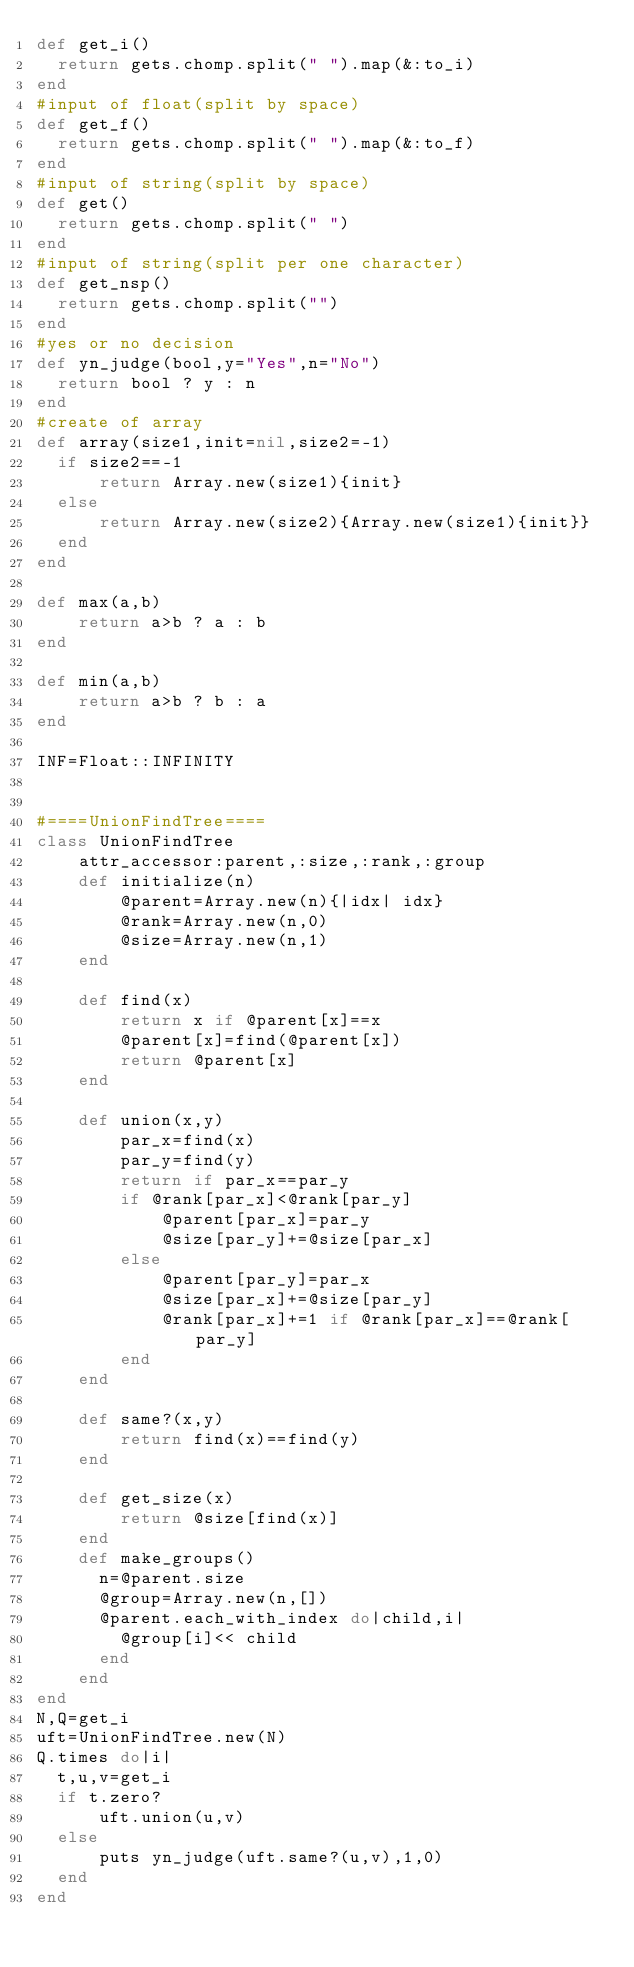Convert code to text. <code><loc_0><loc_0><loc_500><loc_500><_Ruby_>def get_i()
  return gets.chomp.split(" ").map(&:to_i)
end
#input of float(split by space)
def get_f()
  return gets.chomp.split(" ").map(&:to_f)
end
#input of string(split by space)
def get()
  return gets.chomp.split(" ")
end
#input of string(split per one character)
def get_nsp()
  return gets.chomp.split("")
end
#yes or no decision
def yn_judge(bool,y="Yes",n="No")
  return bool ? y : n 
end
#create of array
def array(size1,init=nil,size2=-1)
  if size2==-1
      return Array.new(size1){init}
  else
      return Array.new(size2){Array.new(size1){init}}
  end
end

def max(a,b)
    return a>b ? a : b
end

def min(a,b)
    return a>b ? b : a
end

INF=Float::INFINITY


#====UnionFindTree====
class UnionFindTree
    attr_accessor:parent,:size,:rank,:group
    def initialize(n)
        @parent=Array.new(n){|idx| idx}
        @rank=Array.new(n,0)
        @size=Array.new(n,1)
    end

    def find(x)
        return x if @parent[x]==x
        @parent[x]=find(@parent[x])
        return @parent[x]
    end

    def union(x,y)
        par_x=find(x)
        par_y=find(y)
        return if par_x==par_y
        if @rank[par_x]<@rank[par_y]
            @parent[par_x]=par_y
            @size[par_y]+=@size[par_x]
        else
            @parent[par_y]=par_x
            @size[par_x]+=@size[par_y]
            @rank[par_x]+=1 if @rank[par_x]==@rank[par_y]
        end
    end

    def same?(x,y)
        return find(x)==find(y)
    end

    def get_size(x)
        return @size[find(x)]
    end
    def make_groups()
      n=@parent.size
      @group=Array.new(n,[])
      @parent.each_with_index do|child,i|
        @group[i]<< child 
      end
    end
end
N,Q=get_i
uft=UnionFindTree.new(N)
Q.times do|i|
  t,u,v=get_i
  if t.zero?
      uft.union(u,v)
  else
      puts yn_judge(uft.same?(u,v),1,0)
  end
end</code> 